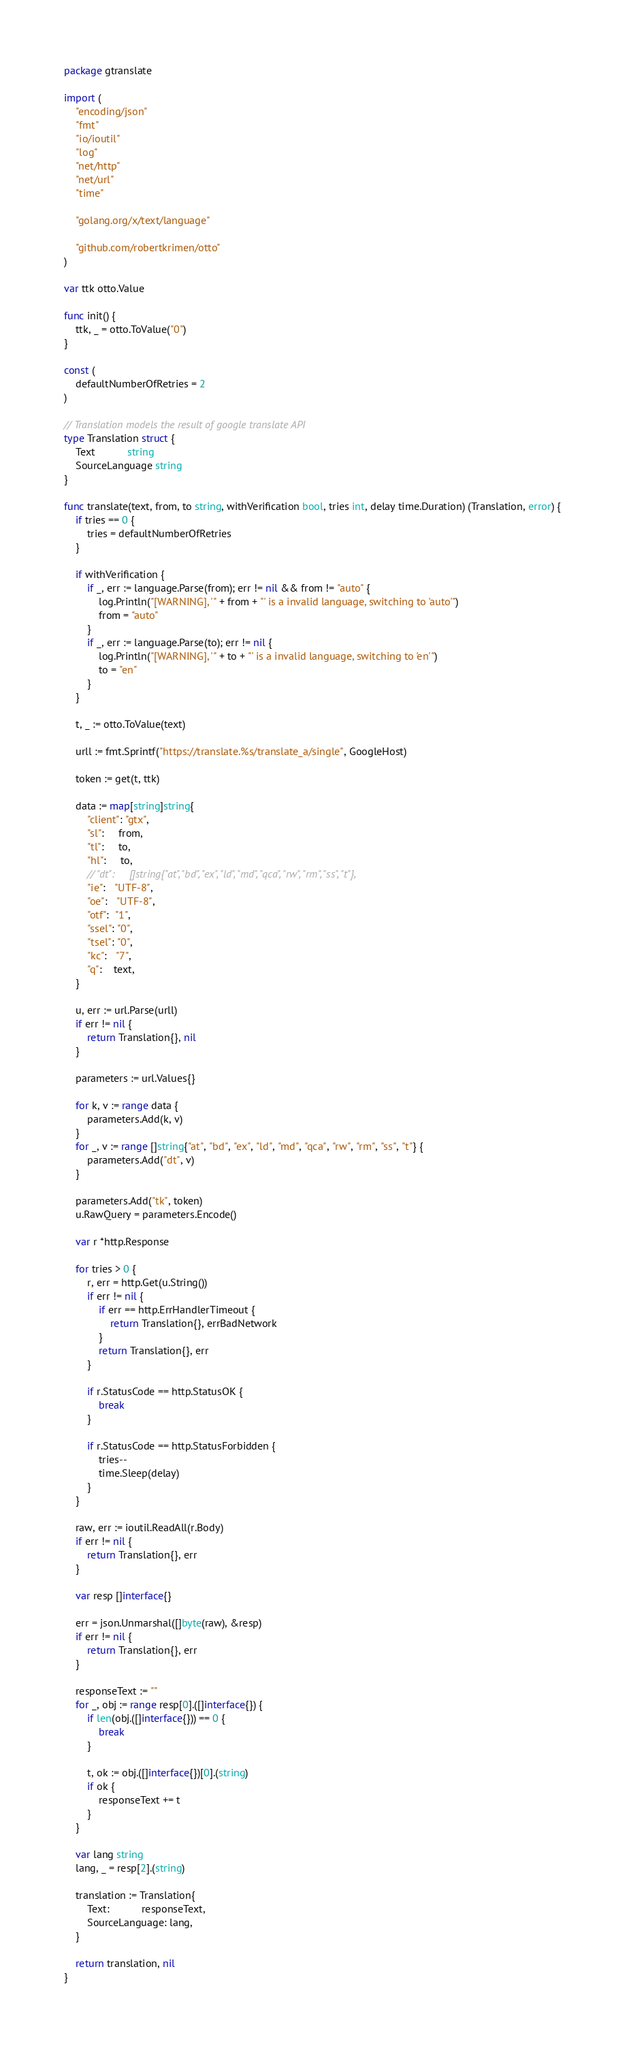Convert code to text. <code><loc_0><loc_0><loc_500><loc_500><_Go_>package gtranslate

import (
	"encoding/json"
	"fmt"
	"io/ioutil"
	"log"
	"net/http"
	"net/url"
	"time"

	"golang.org/x/text/language"

	"github.com/robertkrimen/otto"
)

var ttk otto.Value

func init() {
	ttk, _ = otto.ToValue("0")
}

const (
	defaultNumberOfRetries = 2
)

// Translation models the result of google translate API
type Translation struct {
	Text           string
	SourceLanguage string
}

func translate(text, from, to string, withVerification bool, tries int, delay time.Duration) (Translation, error) {
	if tries == 0 {
		tries = defaultNumberOfRetries
	}

	if withVerification {
		if _, err := language.Parse(from); err != nil && from != "auto" {
			log.Println("[WARNING], '" + from + "' is a invalid language, switching to 'auto'")
			from = "auto"
		}
		if _, err := language.Parse(to); err != nil {
			log.Println("[WARNING], '" + to + "' is a invalid language, switching to 'en'")
			to = "en"
		}
	}

	t, _ := otto.ToValue(text)

	urll := fmt.Sprintf("https://translate.%s/translate_a/single", GoogleHost)

	token := get(t, ttk)

	data := map[string]string{
		"client": "gtx",
		"sl":     from,
		"tl":     to,
		"hl":     to,
		// "dt":     []string{"at", "bd", "ex", "ld", "md", "qca", "rw", "rm", "ss", "t"},
		"ie":   "UTF-8",
		"oe":   "UTF-8",
		"otf":  "1",
		"ssel": "0",
		"tsel": "0",
		"kc":   "7",
		"q":    text,
	}

	u, err := url.Parse(urll)
	if err != nil {
		return Translation{}, nil
	}

	parameters := url.Values{}

	for k, v := range data {
		parameters.Add(k, v)
	}
	for _, v := range []string{"at", "bd", "ex", "ld", "md", "qca", "rw", "rm", "ss", "t"} {
		parameters.Add("dt", v)
	}

	parameters.Add("tk", token)
	u.RawQuery = parameters.Encode()

	var r *http.Response

	for tries > 0 {
		r, err = http.Get(u.String())
		if err != nil {
			if err == http.ErrHandlerTimeout {
				return Translation{}, errBadNetwork
			}
			return Translation{}, err
		}

		if r.StatusCode == http.StatusOK {
			break
		}

		if r.StatusCode == http.StatusForbidden {
			tries--
			time.Sleep(delay)
		}
	}

	raw, err := ioutil.ReadAll(r.Body)
	if err != nil {
		return Translation{}, err
	}

	var resp []interface{}

	err = json.Unmarshal([]byte(raw), &resp)
	if err != nil {
		return Translation{}, err
	}

	responseText := ""
	for _, obj := range resp[0].([]interface{}) {
		if len(obj.([]interface{})) == 0 {
			break
		}

		t, ok := obj.([]interface{})[0].(string)
		if ok {
			responseText += t
		}
	}

	var lang string
	lang, _ = resp[2].(string)

	translation := Translation{
		Text:           responseText,
		SourceLanguage: lang,
	}

	return translation, nil
}
</code> 